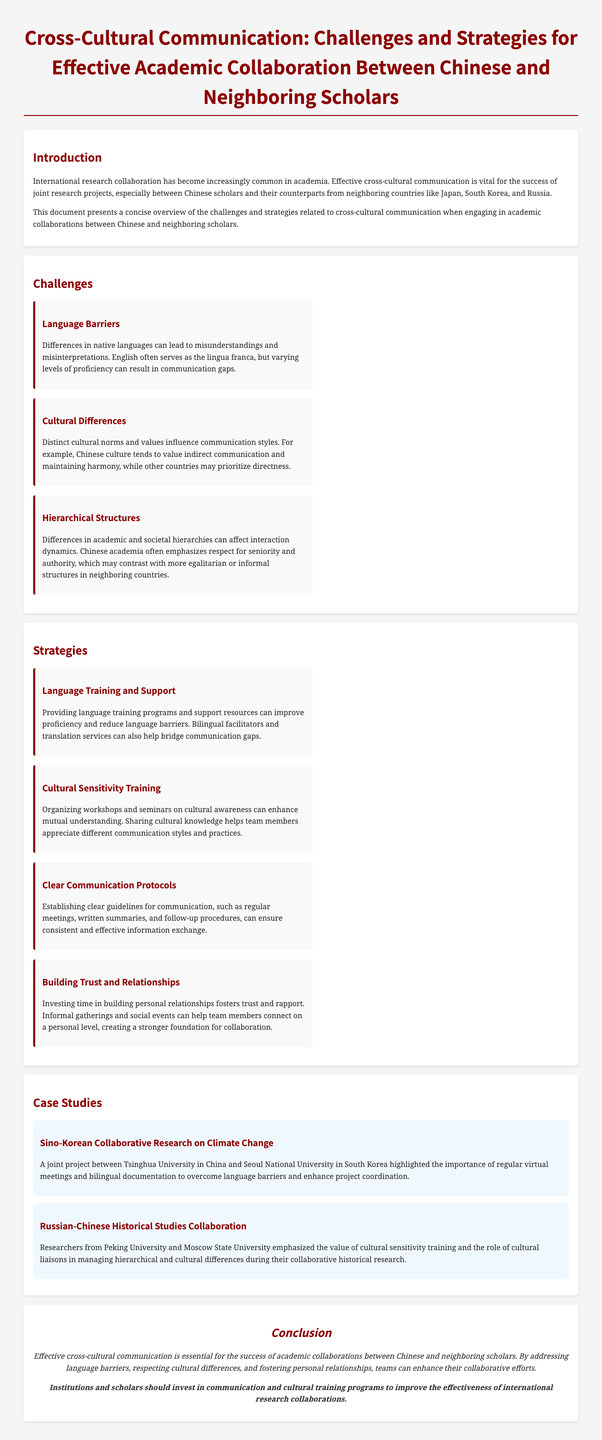What is the title of the document? The title is a key piece of information and can be found at the top of the document.
Answer: Cross-Cultural Communication: Challenges and Strategies for Effective Academic Collaboration Between Chinese and Neighboring Scholars How many main challenges are identified? The number of challenges is listed under the challenges section of the document.
Answer: Three What is a significant barrier mentioned that affects cross-cultural communication? This information can be found in the challenges section, highlighting specific issues.
Answer: Language Barriers Which country does Tsinghua University collaborate with on climate change research? This detail is included in the case studies section, providing specific examples of collaboration.
Answer: South Korea What is one recommended strategy to improve communication? The strategies section details methods to enhance collaboration effectiveness.
Answer: Cultural Sensitivity Training What types of communication protocols are suggested? The strategies section provides specific practices aimed at facilitating communication.
Answer: Clear Communication Protocols What university is mentioned in the case study about historical studies? This information is found in the case studies section, referring to specific academic institutions involved in collaboration.
Answer: Moscow State University What is the conclusion directed towards institutions and scholars? The conclusion summarizes the document’s recommendations for effective collaborations.
Answer: Invest in communication and cultural training programs 